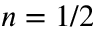Convert formula to latex. <formula><loc_0><loc_0><loc_500><loc_500>n = 1 / 2</formula> 